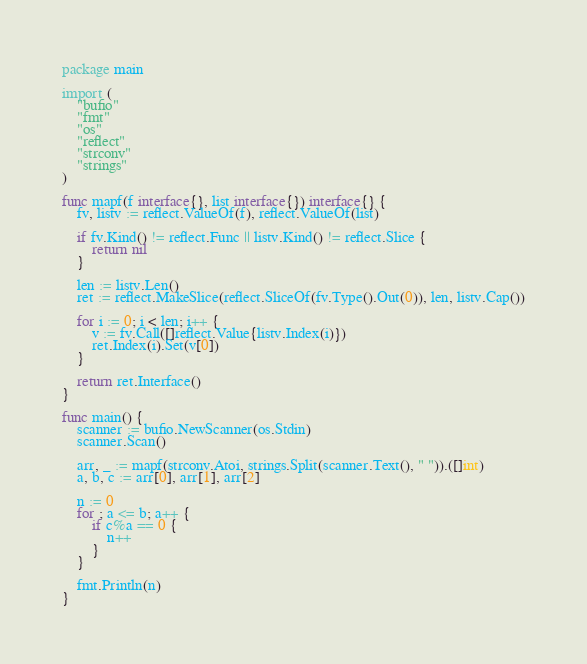<code> <loc_0><loc_0><loc_500><loc_500><_Go_>package main

import (
	"bufio"
	"fmt"
	"os"
	"reflect"
	"strconv"
	"strings"
)

func mapf(f interface{}, list interface{}) interface{} {
	fv, listv := reflect.ValueOf(f), reflect.ValueOf(list)

	if fv.Kind() != reflect.Func || listv.Kind() != reflect.Slice {
		return nil
	}

	len := listv.Len()
	ret := reflect.MakeSlice(reflect.SliceOf(fv.Type().Out(0)), len, listv.Cap())

	for i := 0; i < len; i++ {
		v := fv.Call([]reflect.Value{listv.Index(i)})
		ret.Index(i).Set(v[0])
	}

	return ret.Interface()
}

func main() {
	scanner := bufio.NewScanner(os.Stdin)
	scanner.Scan()

	arr, _ := mapf(strconv.Atoi, strings.Split(scanner.Text(), " ")).([]int)
	a, b, c := arr[0], arr[1], arr[2]

	n := 0
	for ; a <= b; a++ {
		if c%a == 0 {
			n++
		}
	}

	fmt.Println(n)
}

</code> 